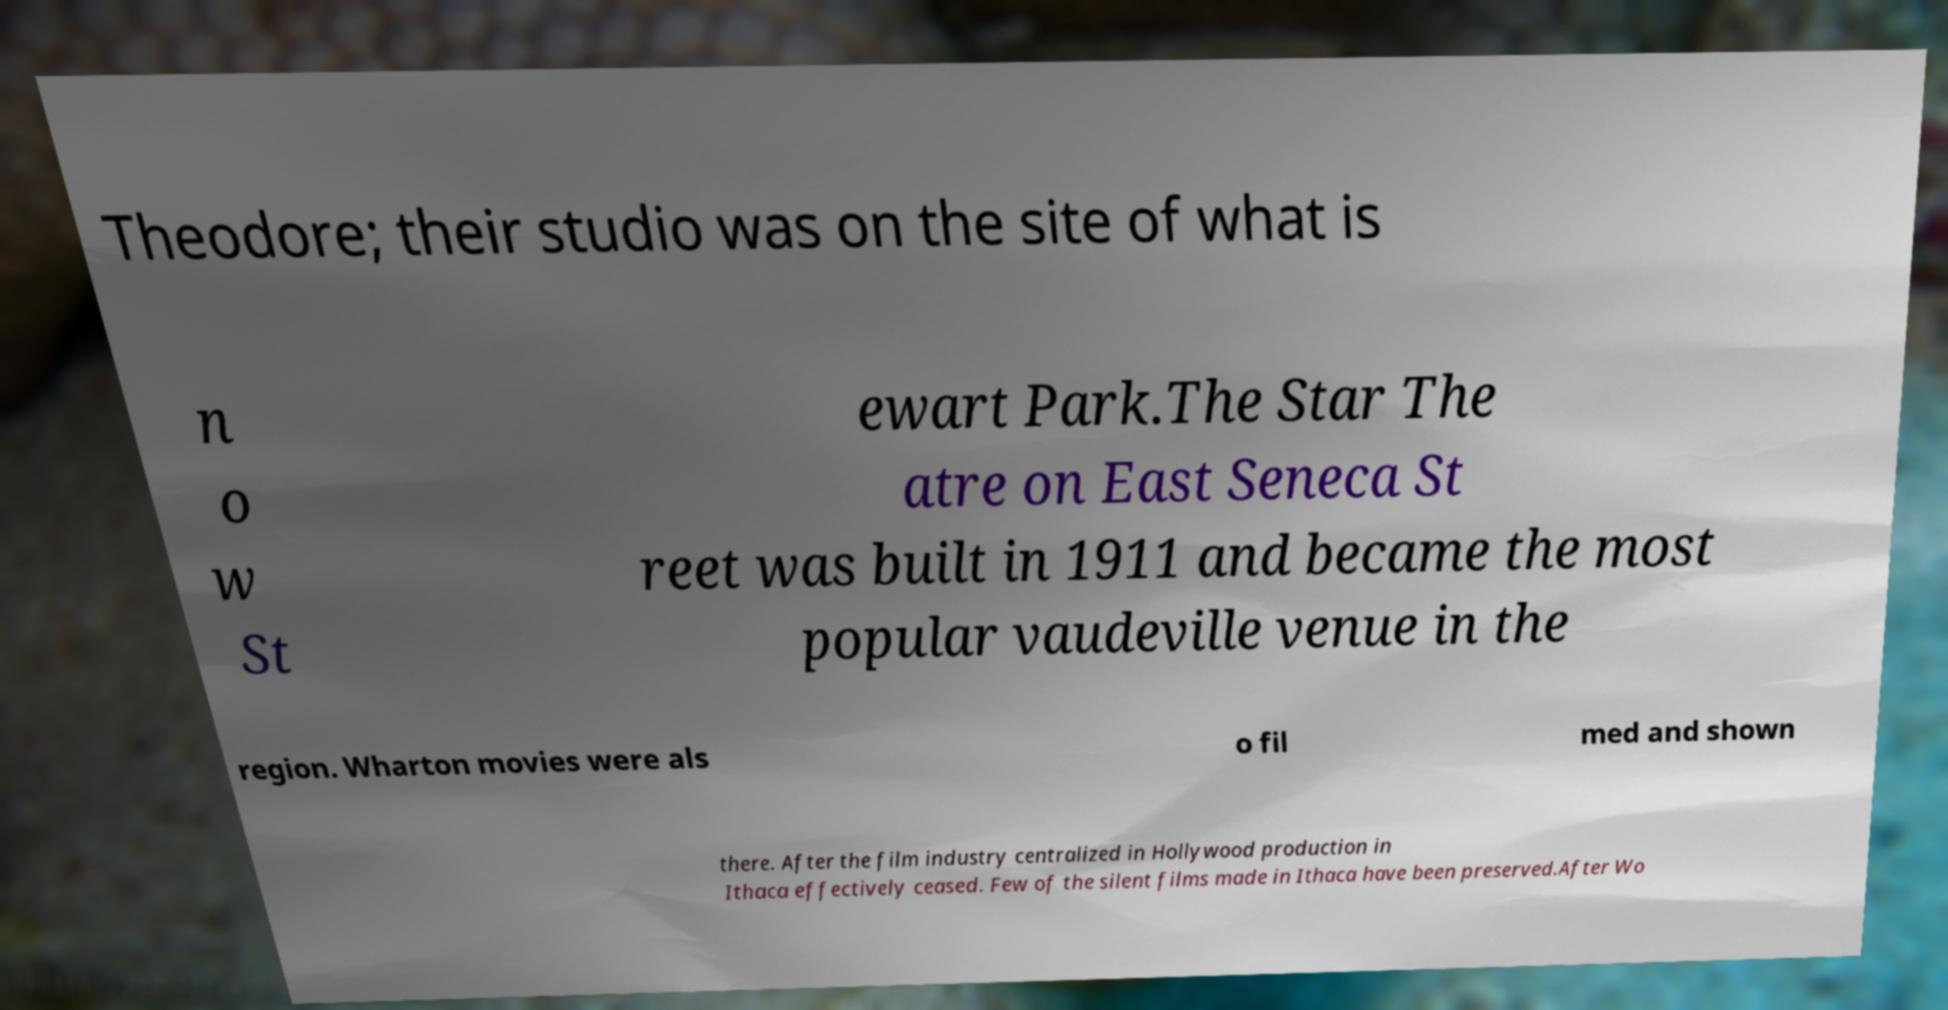What messages or text are displayed in this image? I need them in a readable, typed format. Theodore; their studio was on the site of what is n o w St ewart Park.The Star The atre on East Seneca St reet was built in 1911 and became the most popular vaudeville venue in the region. Wharton movies were als o fil med and shown there. After the film industry centralized in Hollywood production in Ithaca effectively ceased. Few of the silent films made in Ithaca have been preserved.After Wo 